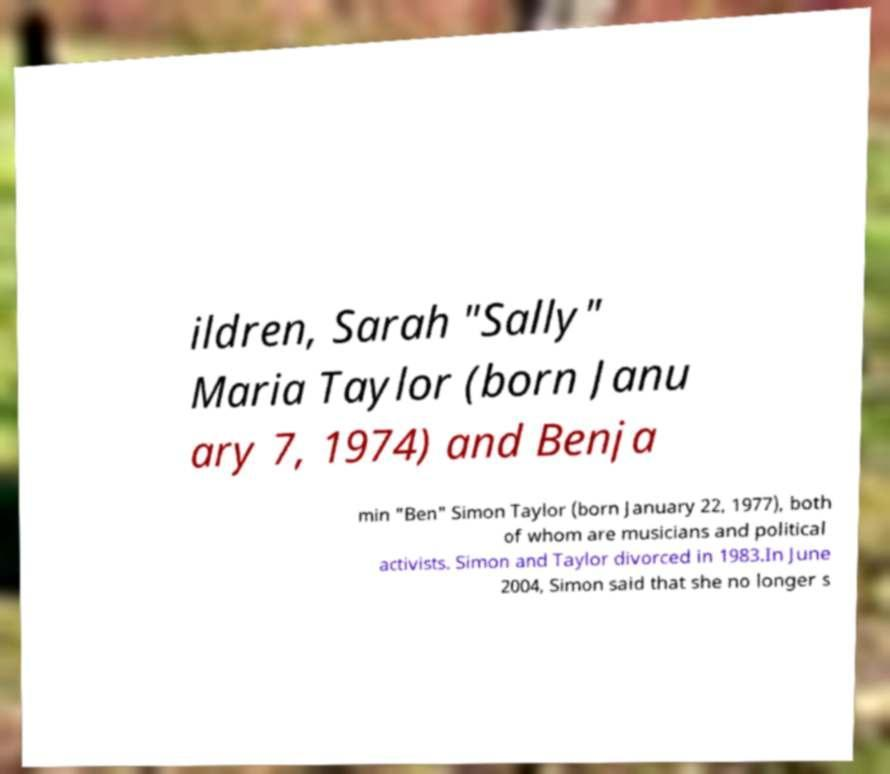Can you read and provide the text displayed in the image?This photo seems to have some interesting text. Can you extract and type it out for me? ildren, Sarah "Sally" Maria Taylor (born Janu ary 7, 1974) and Benja min "Ben" Simon Taylor (born January 22, 1977), both of whom are musicians and political activists. Simon and Taylor divorced in 1983.In June 2004, Simon said that she no longer s 